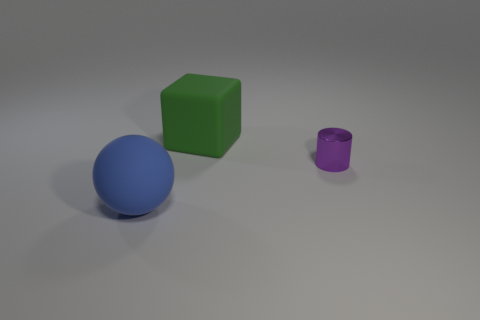What is the material of the small purple thing that is right of the blue matte sphere?
Offer a terse response. Metal. Is there a big yellow object that has the same shape as the green matte thing?
Provide a short and direct response. No. What number of other objects are there of the same shape as the large blue object?
Offer a very short reply. 0. Does the purple object have the same shape as the matte object to the right of the rubber ball?
Offer a very short reply. No. Are there any other things that have the same material as the tiny object?
Your response must be concise. No. What number of tiny things are purple metal cylinders or matte blocks?
Offer a terse response. 1. Is the number of large blue things that are in front of the large green rubber thing less than the number of things that are on the left side of the small thing?
Ensure brevity in your answer.  Yes. How many objects are purple objects or big green objects?
Give a very brief answer. 2. There is a green rubber cube; how many cylinders are behind it?
Keep it short and to the point. 0. Is the color of the cylinder the same as the large matte ball?
Provide a succinct answer. No. 